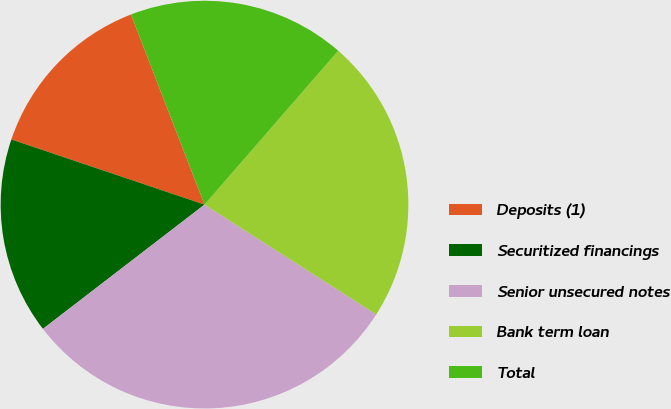Convert chart. <chart><loc_0><loc_0><loc_500><loc_500><pie_chart><fcel>Deposits (1)<fcel>Securitized financings<fcel>Senior unsecured notes<fcel>Bank term loan<fcel>Total<nl><fcel>13.95%<fcel>15.61%<fcel>30.51%<fcel>22.67%<fcel>17.26%<nl></chart> 